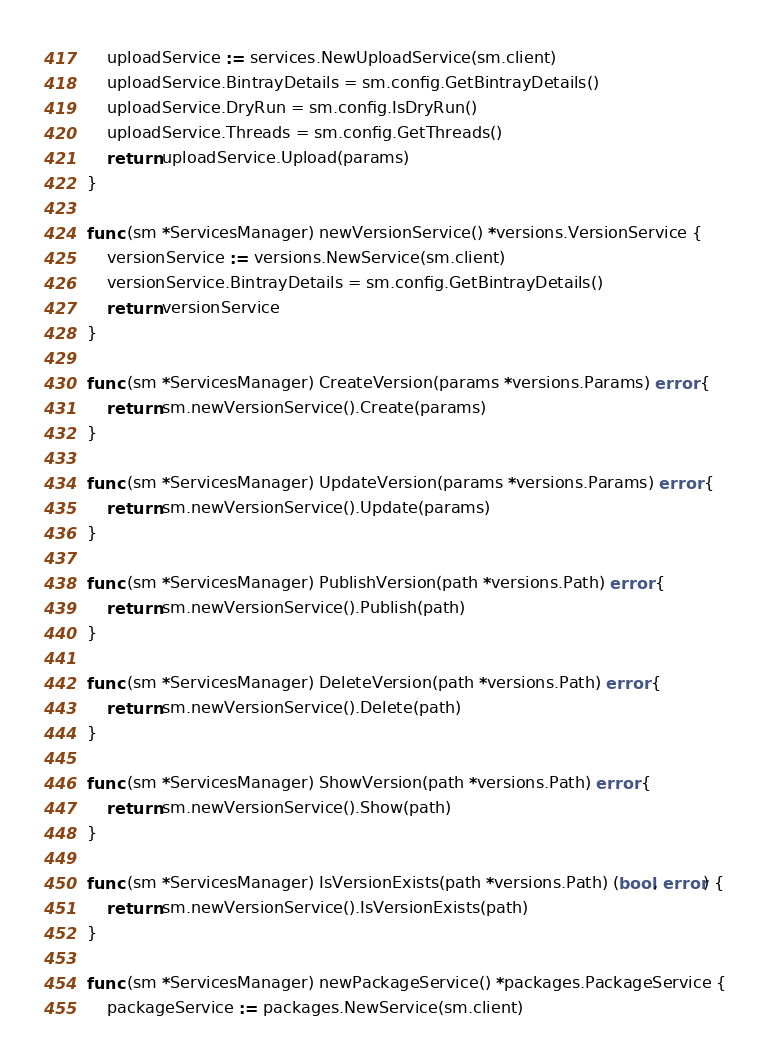Convert code to text. <code><loc_0><loc_0><loc_500><loc_500><_Go_>	uploadService := services.NewUploadService(sm.client)
	uploadService.BintrayDetails = sm.config.GetBintrayDetails()
	uploadService.DryRun = sm.config.IsDryRun()
	uploadService.Threads = sm.config.GetThreads()
	return uploadService.Upload(params)
}

func (sm *ServicesManager) newVersionService() *versions.VersionService {
	versionService := versions.NewService(sm.client)
	versionService.BintrayDetails = sm.config.GetBintrayDetails()
	return versionService
}

func (sm *ServicesManager) CreateVersion(params *versions.Params) error {
	return sm.newVersionService().Create(params)
}

func (sm *ServicesManager) UpdateVersion(params *versions.Params) error {
	return sm.newVersionService().Update(params)
}

func (sm *ServicesManager) PublishVersion(path *versions.Path) error {
	return sm.newVersionService().Publish(path)
}

func (sm *ServicesManager) DeleteVersion(path *versions.Path) error {
	return sm.newVersionService().Delete(path)
}

func (sm *ServicesManager) ShowVersion(path *versions.Path) error {
	return sm.newVersionService().Show(path)
}

func (sm *ServicesManager) IsVersionExists(path *versions.Path) (bool, error) {
	return sm.newVersionService().IsVersionExists(path)
}

func (sm *ServicesManager) newPackageService() *packages.PackageService {
	packageService := packages.NewService(sm.client)</code> 